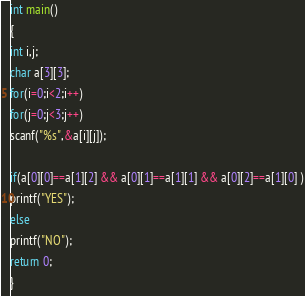<code> <loc_0><loc_0><loc_500><loc_500><_C_>
int main()
{
int i,j;
char a[3][3];
for(i=0;i<2;i++)
for(j=0;j<3;j++)
scanf("%s",&a[i][j]);

if(a[0][0]==a[1][2] && a[0][1]==a[1][1] && a[0][2]==a[1][0] )
printf("YES");
else
printf("NO");
return 0;
}
</code> 